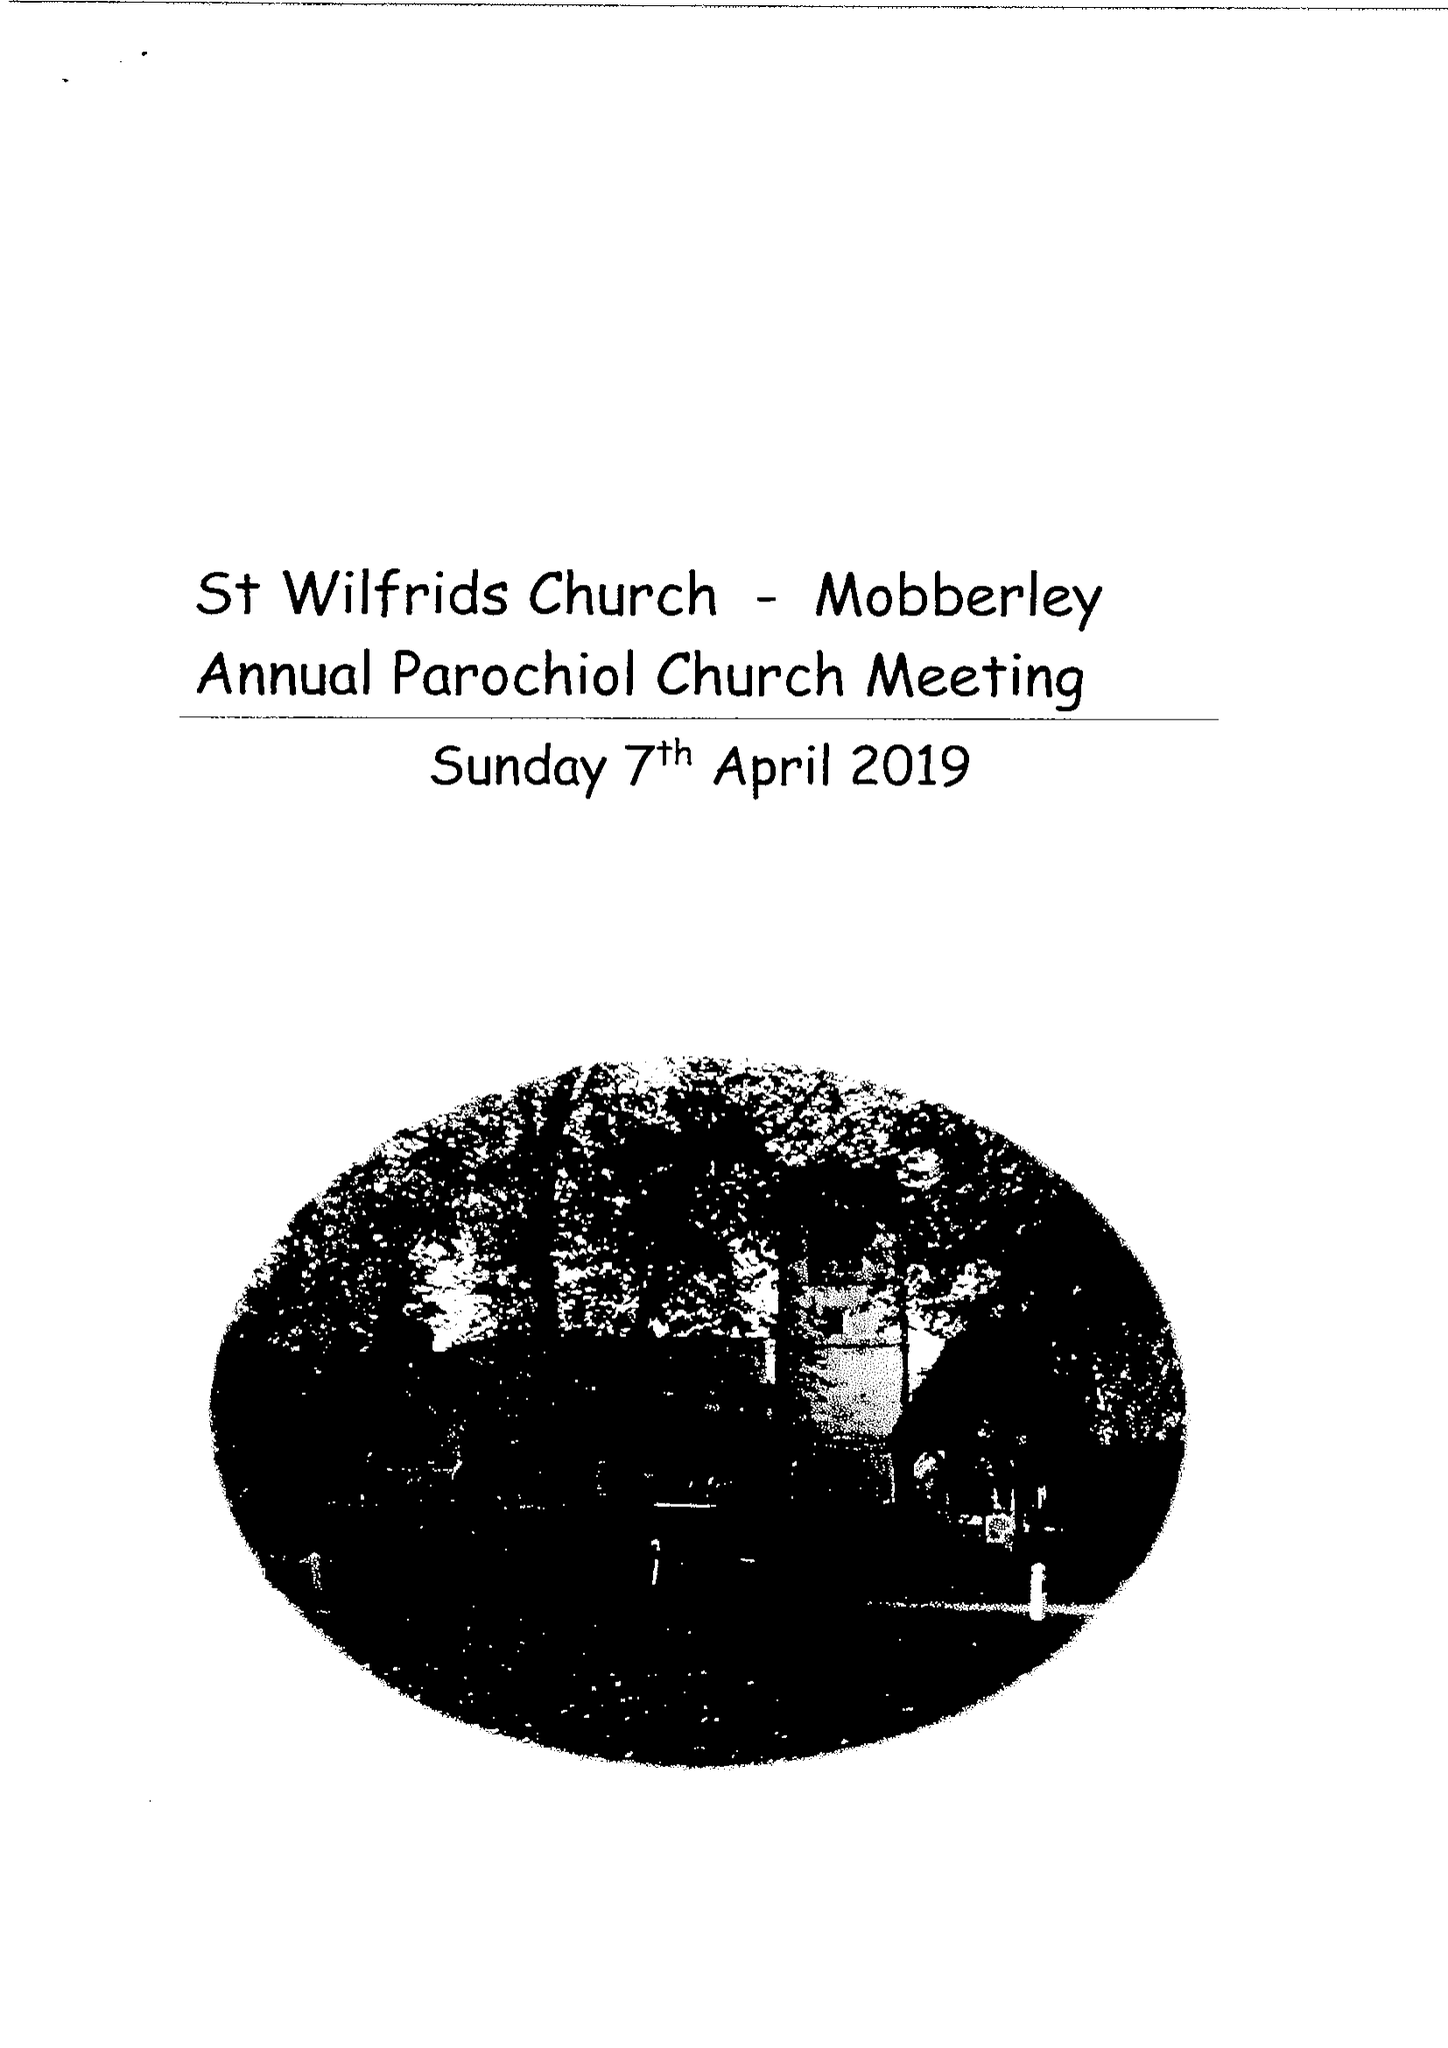What is the value for the report_date?
Answer the question using a single word or phrase. 2018-12-31 